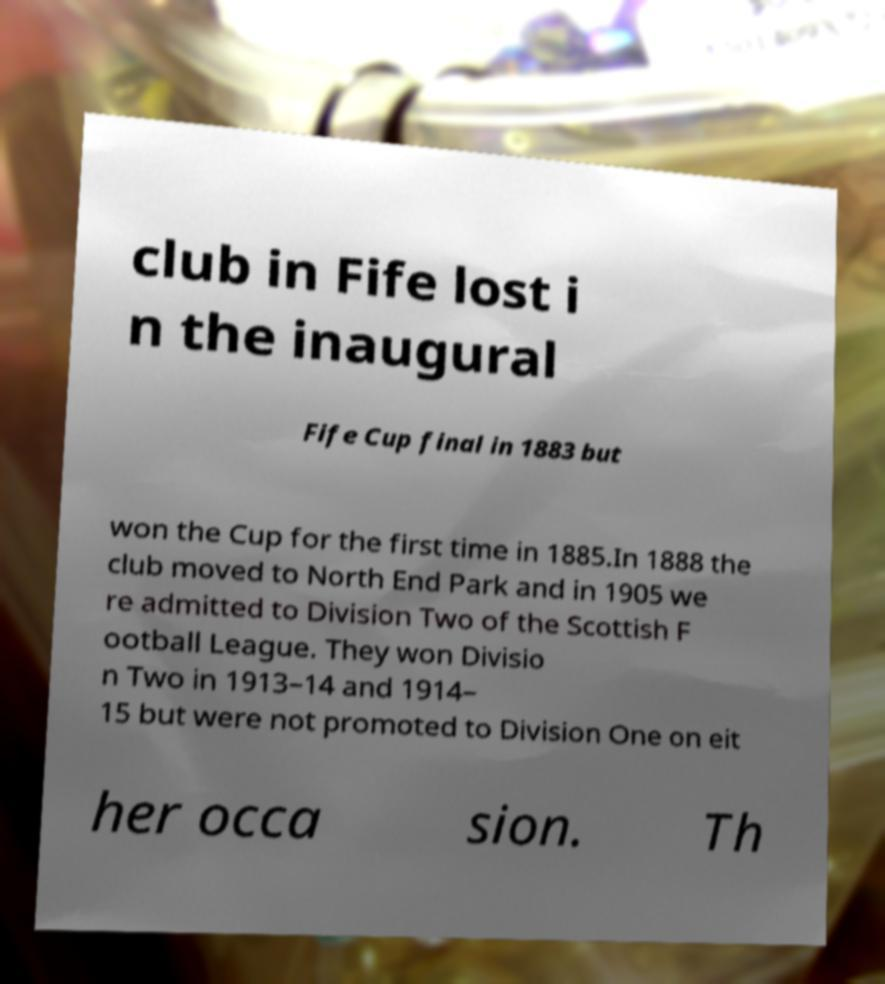Could you assist in decoding the text presented in this image and type it out clearly? club in Fife lost i n the inaugural Fife Cup final in 1883 but won the Cup for the first time in 1885.In 1888 the club moved to North End Park and in 1905 we re admitted to Division Two of the Scottish F ootball League. They won Divisio n Two in 1913–14 and 1914– 15 but were not promoted to Division One on eit her occa sion. Th 